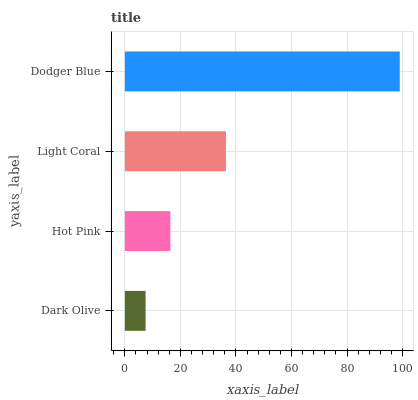Is Dark Olive the minimum?
Answer yes or no. Yes. Is Dodger Blue the maximum?
Answer yes or no. Yes. Is Hot Pink the minimum?
Answer yes or no. No. Is Hot Pink the maximum?
Answer yes or no. No. Is Hot Pink greater than Dark Olive?
Answer yes or no. Yes. Is Dark Olive less than Hot Pink?
Answer yes or no. Yes. Is Dark Olive greater than Hot Pink?
Answer yes or no. No. Is Hot Pink less than Dark Olive?
Answer yes or no. No. Is Light Coral the high median?
Answer yes or no. Yes. Is Hot Pink the low median?
Answer yes or no. Yes. Is Dark Olive the high median?
Answer yes or no. No. Is Dark Olive the low median?
Answer yes or no. No. 